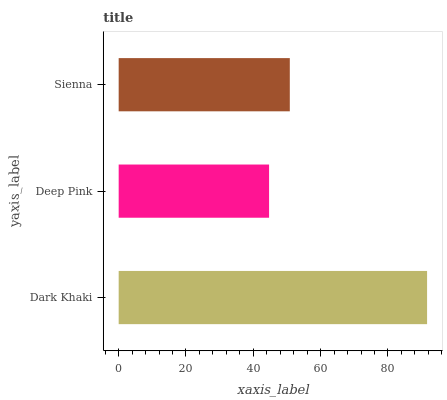Is Deep Pink the minimum?
Answer yes or no. Yes. Is Dark Khaki the maximum?
Answer yes or no. Yes. Is Sienna the minimum?
Answer yes or no. No. Is Sienna the maximum?
Answer yes or no. No. Is Sienna greater than Deep Pink?
Answer yes or no. Yes. Is Deep Pink less than Sienna?
Answer yes or no. Yes. Is Deep Pink greater than Sienna?
Answer yes or no. No. Is Sienna less than Deep Pink?
Answer yes or no. No. Is Sienna the high median?
Answer yes or no. Yes. Is Sienna the low median?
Answer yes or no. Yes. Is Dark Khaki the high median?
Answer yes or no. No. Is Dark Khaki the low median?
Answer yes or no. No. 